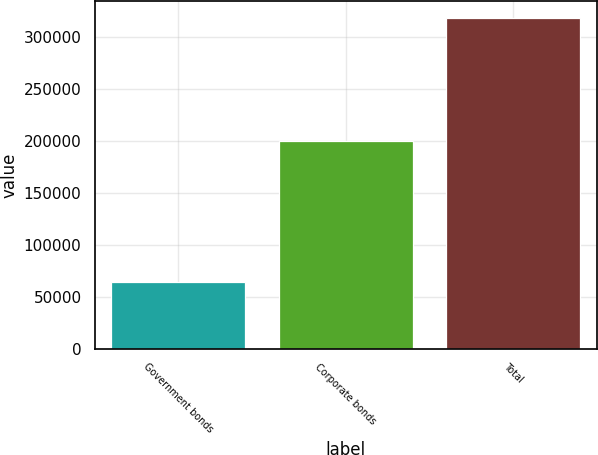Convert chart to OTSL. <chart><loc_0><loc_0><loc_500><loc_500><bar_chart><fcel>Government bonds<fcel>Corporate bonds<fcel>Total<nl><fcel>63674<fcel>200120<fcel>318398<nl></chart> 